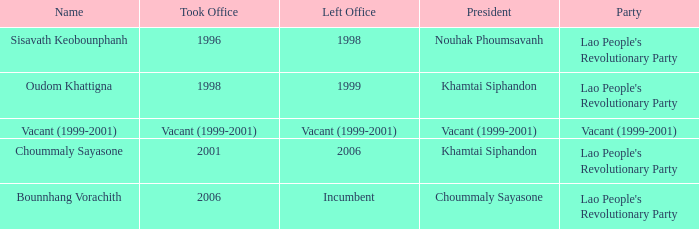What is the political group when the name is oudom khattigna? Lao People's Revolutionary Party. 